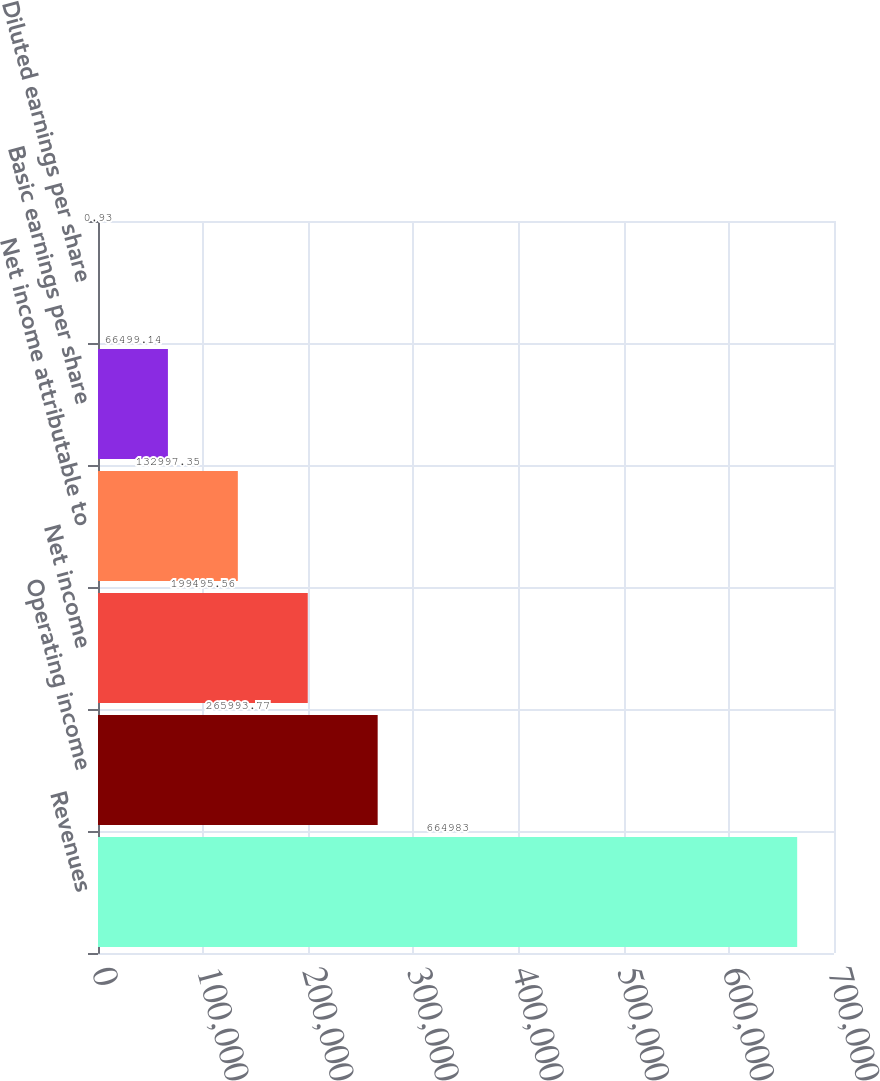<chart> <loc_0><loc_0><loc_500><loc_500><bar_chart><fcel>Revenues<fcel>Operating income<fcel>Net income<fcel>Net income attributable to<fcel>Basic earnings per share<fcel>Diluted earnings per share<nl><fcel>664983<fcel>265994<fcel>199496<fcel>132997<fcel>66499.1<fcel>0.93<nl></chart> 